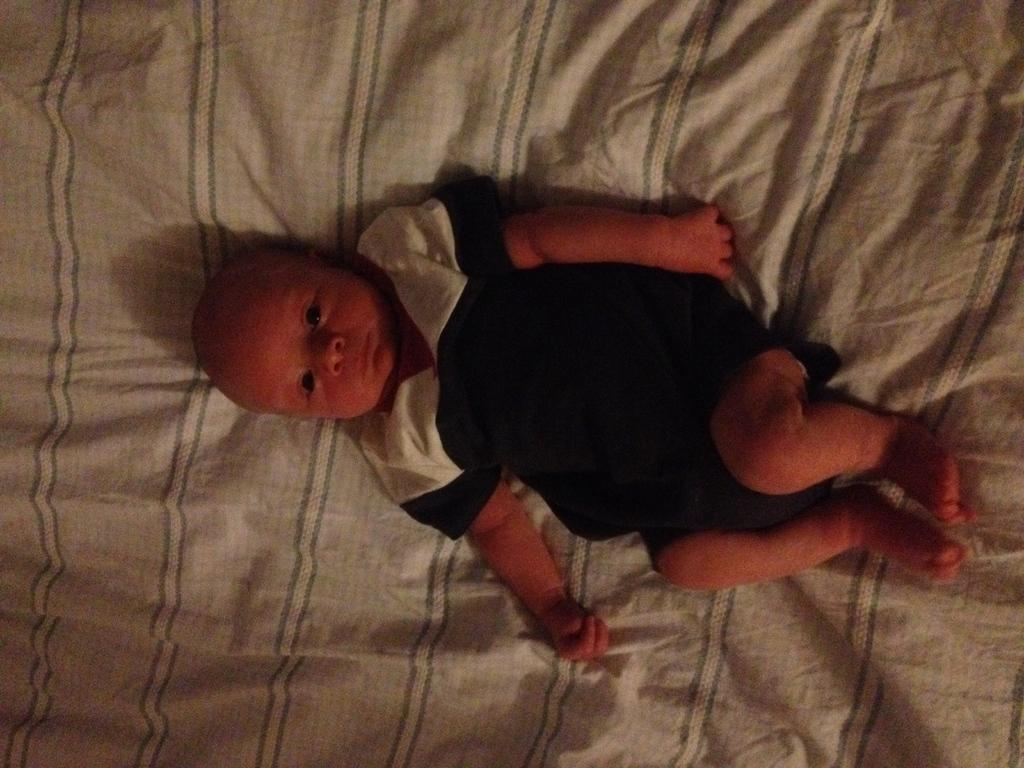What is the main subject of the image? There is a baby in the image. Where is the baby located? The baby is lying on a bed. Can you see any ladybugs crawling on the baby in the image? No, there are no ladybugs present in the image. Where is the lunchroom in the image? There is no mention of a lunchroom in the image; it only features a baby lying on a bed. 